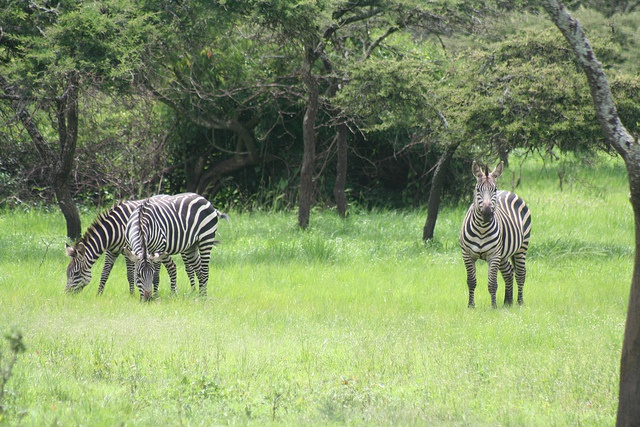Describe the objects in this image and their specific colors. I can see zebra in darkgreen, gray, darkgray, lightgray, and black tones, zebra in darkgreen, gray, darkgray, olive, and black tones, and zebra in darkgreen, gray, black, darkgray, and olive tones in this image. 